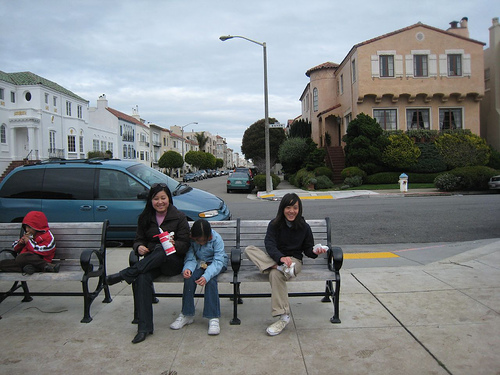Can you tell me more about the setting they are in? Certainly! The image shows a street setting, indicative of a residential area with a calm and orderly atmosphere. The row of houses along the street suggests a suburban environment, with architecture that points to mid-20th century design. The clear roads and comfortable seating area indicate a community-oriented neighborhood, possibly one that values outdoor interaction and pedestrian-friendly spaces. 